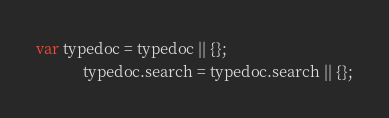Convert code to text. <code><loc_0><loc_0><loc_500><loc_500><_JavaScript_>var typedoc = typedoc || {};
            typedoc.search = typedoc.search || {};</code> 